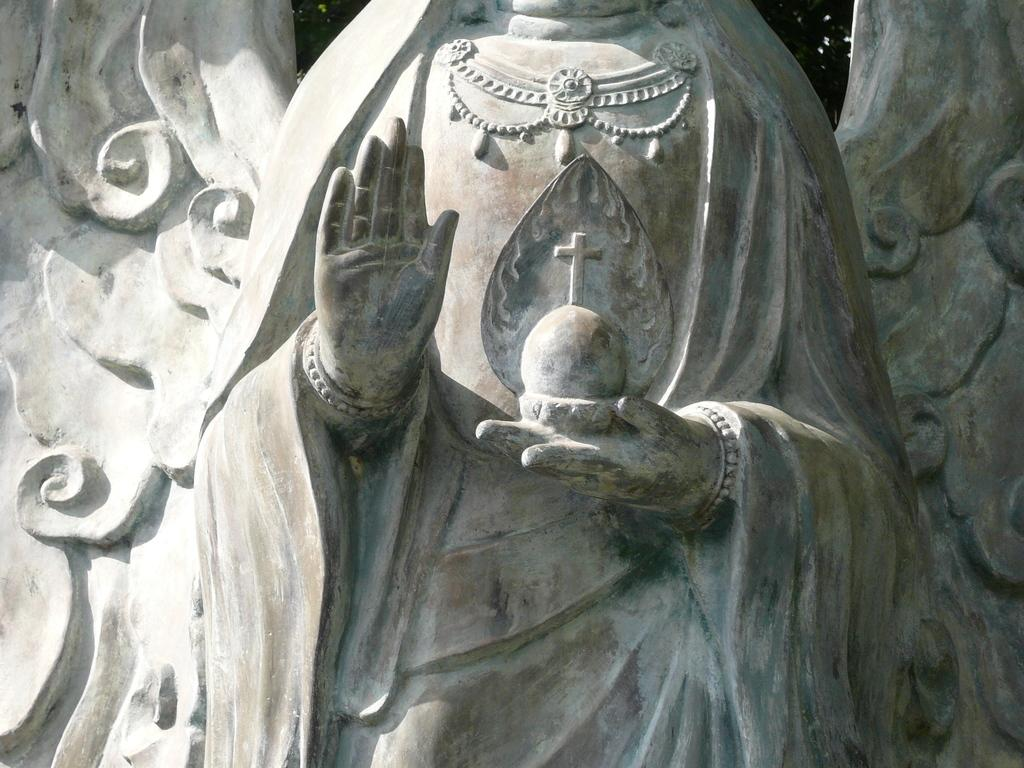What is the main subject of the image? The main subject of the image is a sculpture. What is the sculpture depicting? The sculpture is of a person. Where is the sculpture located in the image? The sculpture is in the middle of the image. How many grapes are on the sculpture in the image? There are no grapes present on the sculpture in the image. What type of material is the sculpture made of in the image? The provided facts do not mention the material of the sculpture, so we cannot determine its composition from the image. 